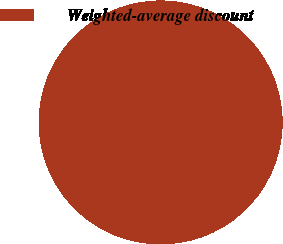Convert chart. <chart><loc_0><loc_0><loc_500><loc_500><pie_chart><fcel>Weighted-average discount<nl><fcel>100.0%<nl></chart> 